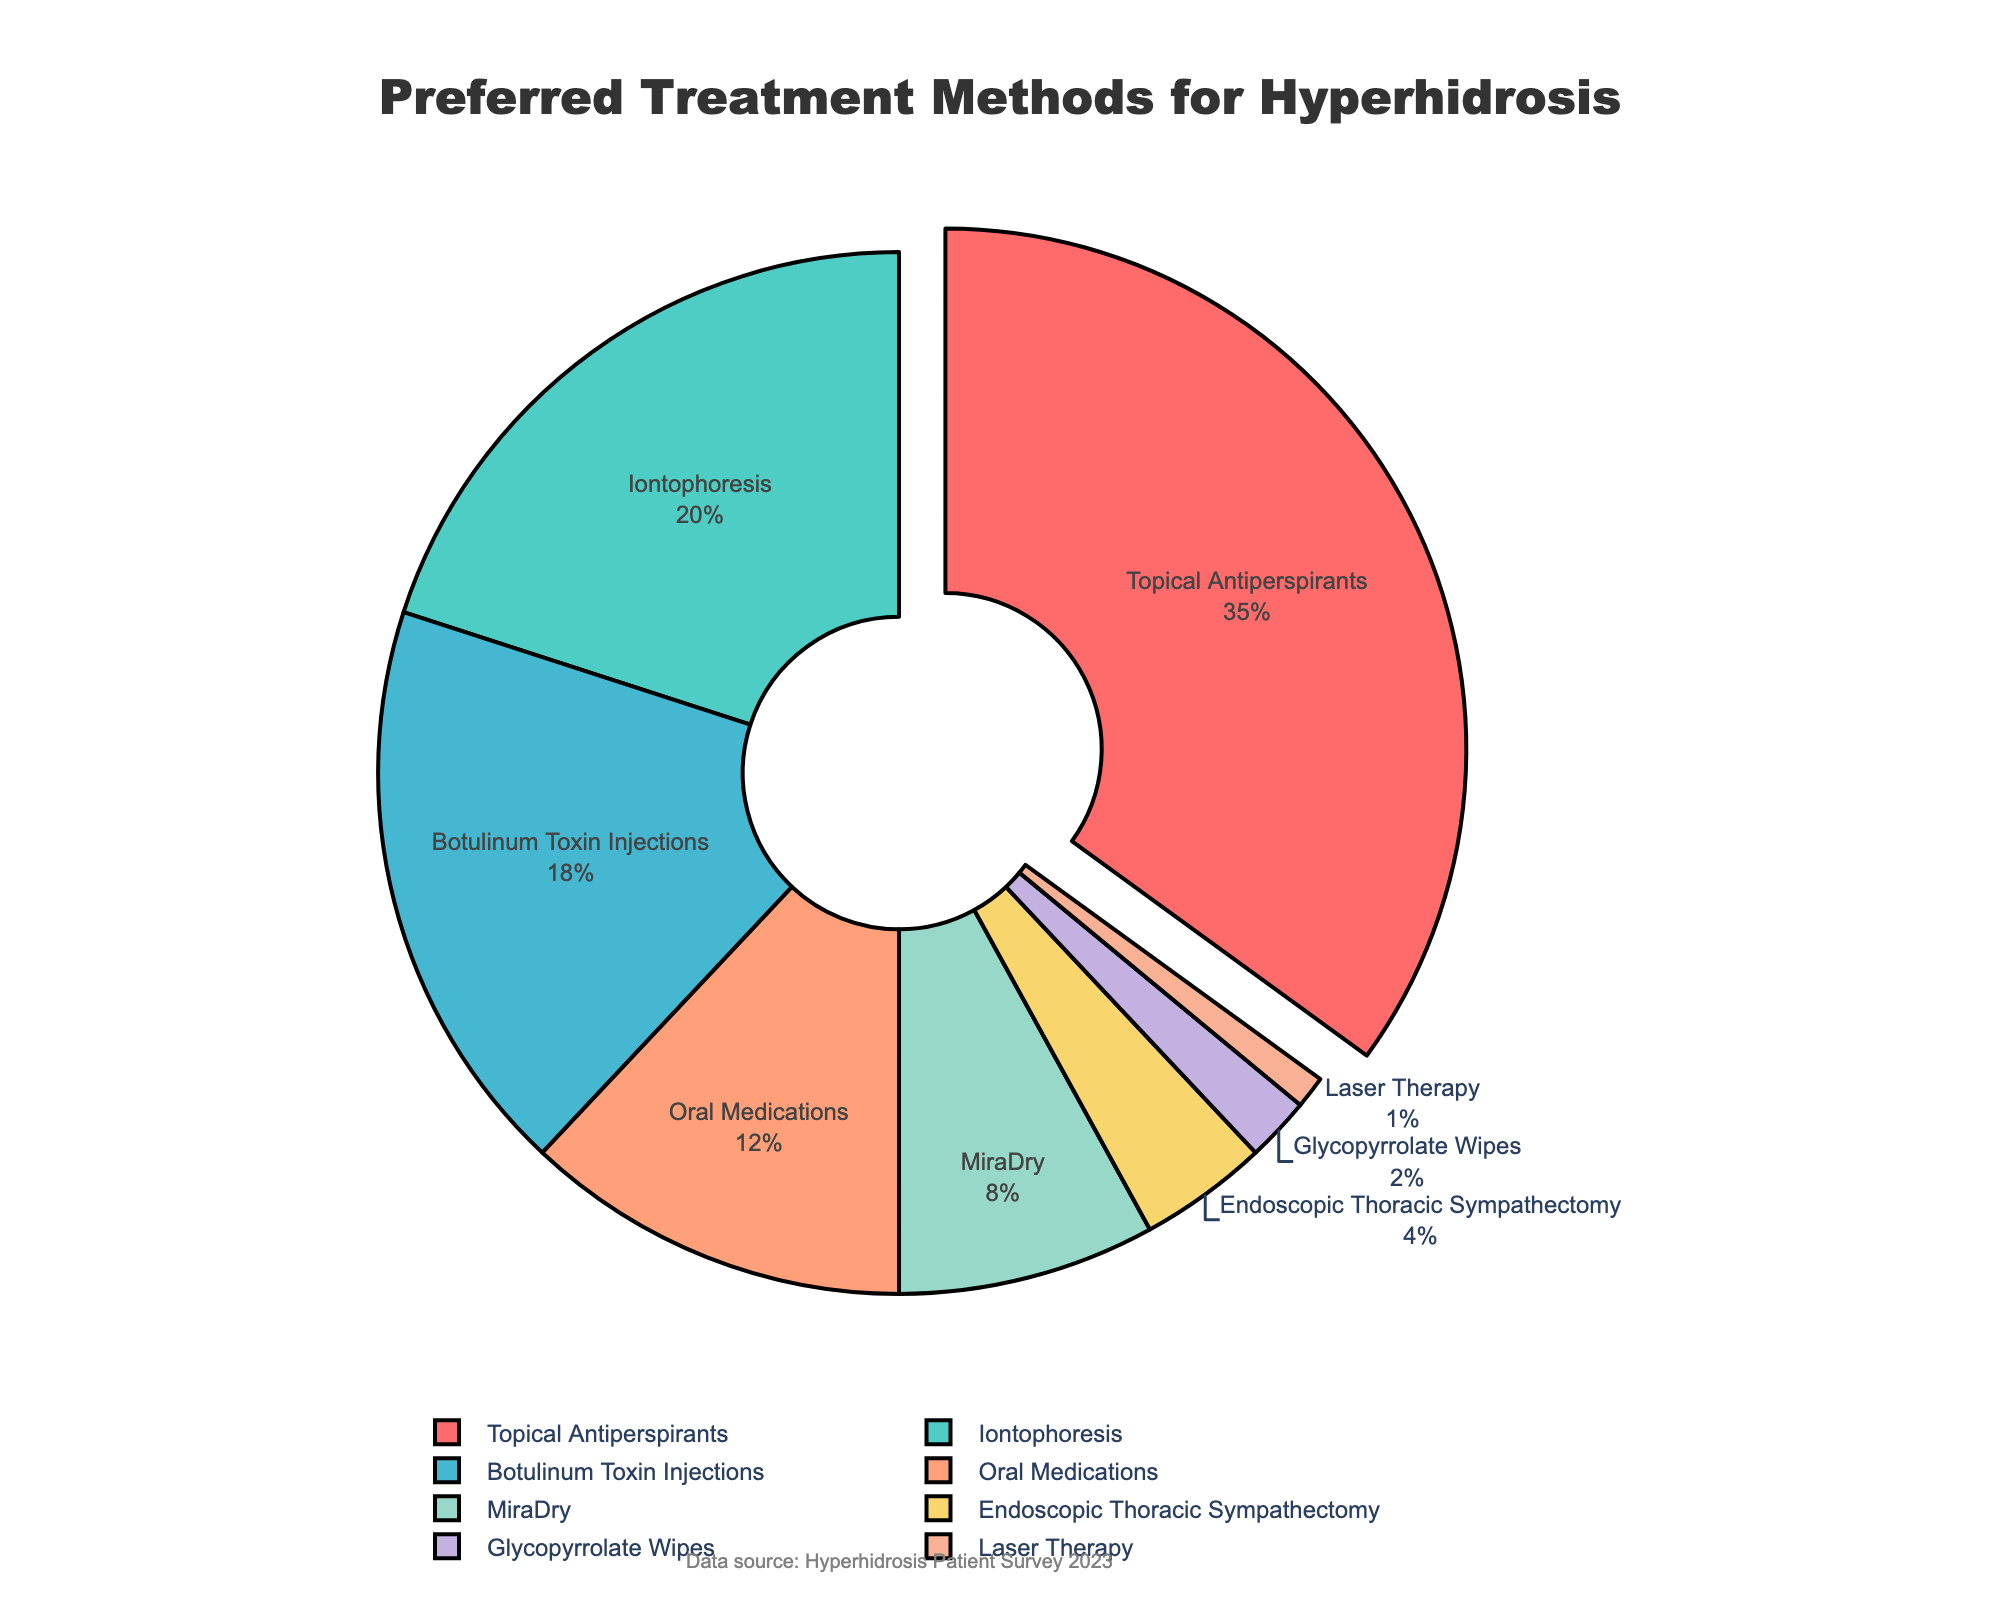What's the most preferred treatment method for hyperhidrosis patients? The pie chart indicates the percentage distribution of various treatment methods for hyperhidrosis. The slice with the highest percentage represents the most preferred treatment method. We can see that "Topical Antiperspirants" has the largest slice at 35%.
Answer: Topical Antiperspirants Which treatment method is preferred by more patients, Botulinum Toxin Injections or Oral Medications? To determine which treatment method is preferred by more patients, we compare the percentages of Botulinum Toxin Injections (18%) and Oral Medications (12%). Since 18% is greater than 12%, Botulinum Toxin Injections is preferred by more patients.
Answer: Botulinum Toxin Injections What is the combined percentage of patients who prefer either Endoscopic Thoracic Sympathectomy or Glycopyrrolate Wipes? We need to add the percentages of patients who prefer Endoscopic Thoracic Sympathectomy (4%) and Glycopyrrolate Wipes (2%). The combined percentage is 4% + 2% = 6%.
Answer: 6% Which treatment methods have a preference percentage below 10%? Observing the pie chart, we identify the treatment methods with percentages below 10%. These are MiraDry (8%), Endoscopic Thoracic Sympathectomy (4%), Glycopyrrolate Wipes (2%), and Laser Therapy (1%).
Answer: MiraDry, Endoscopic Thoracic Sympathectomy, Glycopyrrolate Wipes, Laser Therapy By how much does the percentage of patients preferring Iontophoresis exceed the percentage preferring MiraDry? We compare the percentages of Iontophoresis (20%) and MiraDry (8%). The difference is found by subtracting 8% from 20%, resulting in 20% - 8% = 12%.
Answer: 12% What color represents the slice for Oral Medications? The pie chart uses specific colors to differentiate between treatment methods. By observing the visual attributes in the legend, we notice that Oral Medications are represented by a light salmon color.
Answer: light salmon Which treatment has the smallest percentage of patient preference, and what is its percentage? From the pie chart, we identify the smallest slice, which represents the least preferred treatment method. Laser Therapy has the smallest slice, with a percentage of 1%.
Answer: Laser Therapy, 1% What is the total percentage of patients preferring treatments other than Topical Antiperspirants? To find this, we subtract the percentage of patients preferring Topical Antiperspirants (35%) from the total percentage (100%). The calculation is 100% - 35% = 65%.
Answer: 65% What is the ratio of patients who prefer Botulinum Toxin Injections to those who prefer Glycopyrrolate Wipes? To find the ratio, we divide the percentage of patients preferring Botulinum Toxin Injections (18%) by the percentage preferring Glycopyrrolate Wipes (2%). The ratio is 18% / 2% = 9. This can be expressed as 9:1.
Answer: 9:1 How many treatment methods have a percentage greater than or equal to 10%? We look at the percentages for each treatment method: 35%, 20%, 18%, and 12% are all greater than or equal to 10%. This sums up to four treatment methods.
Answer: 4 